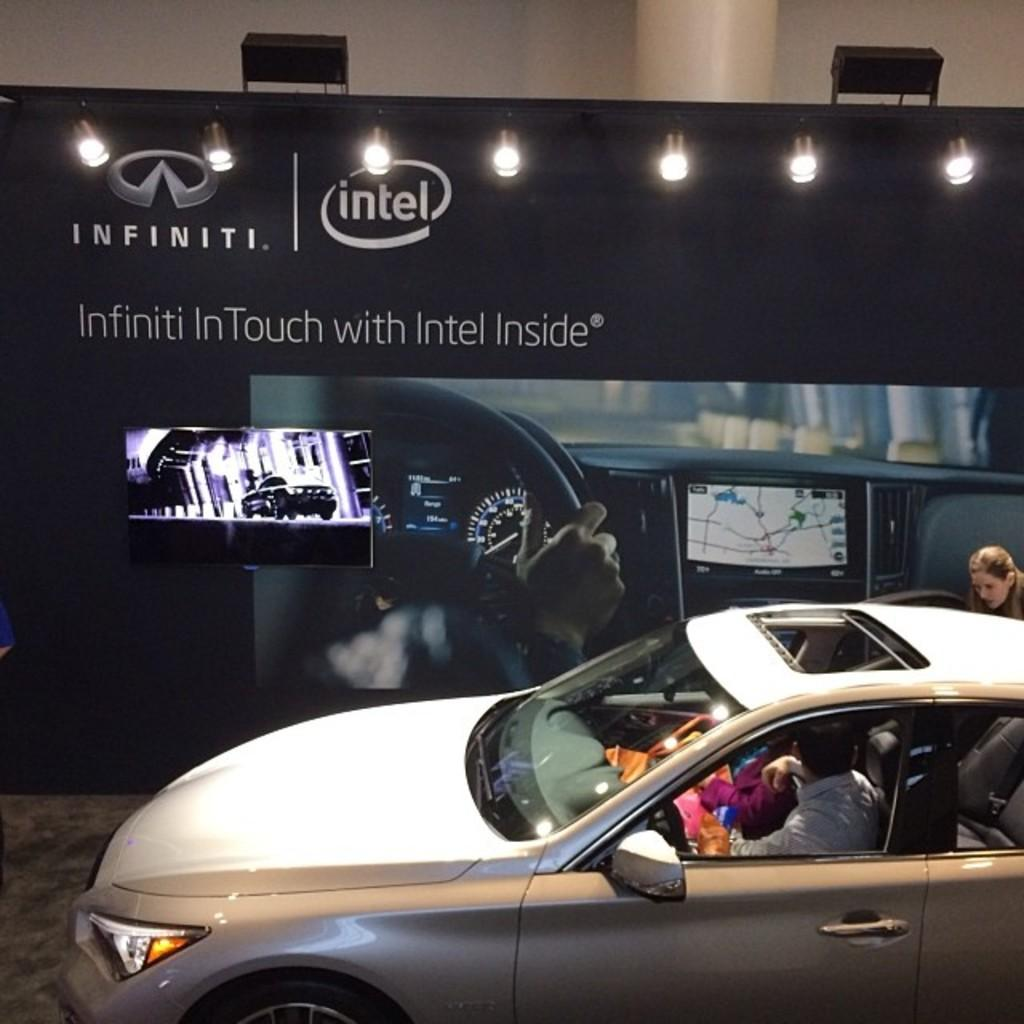What type of vehicle is in the image? There is a white car in the image. Who or what is inside the car? There are persons sitting in the car. What can be seen on the wall in the background of the image? There are lights on the wall in the background of the image. What is hanging in the background of the image? There is a banner in the background of the image. What type of spoon is being used to stir the competition in the image? There is no competition or spoon present in the image. 